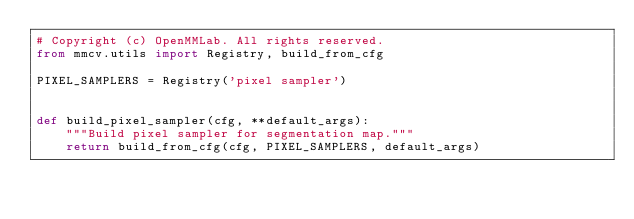Convert code to text. <code><loc_0><loc_0><loc_500><loc_500><_Python_># Copyright (c) OpenMMLab. All rights reserved.
from mmcv.utils import Registry, build_from_cfg

PIXEL_SAMPLERS = Registry('pixel sampler')


def build_pixel_sampler(cfg, **default_args):
    """Build pixel sampler for segmentation map."""
    return build_from_cfg(cfg, PIXEL_SAMPLERS, default_args)
</code> 